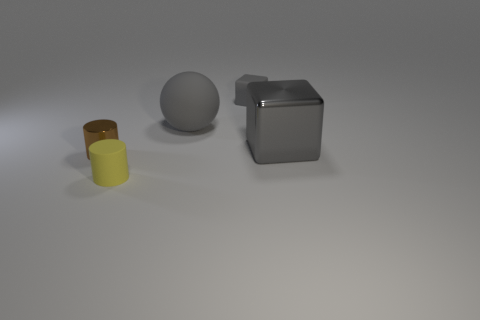Add 3 cyan matte cylinders. How many objects exist? 8 Subtract all spheres. How many objects are left? 4 Subtract 0 green cubes. How many objects are left? 5 Subtract all shiny objects. Subtract all tiny brown cylinders. How many objects are left? 2 Add 3 tiny gray rubber cubes. How many tiny gray rubber cubes are left? 4 Add 5 large gray metallic cubes. How many large gray metallic cubes exist? 6 